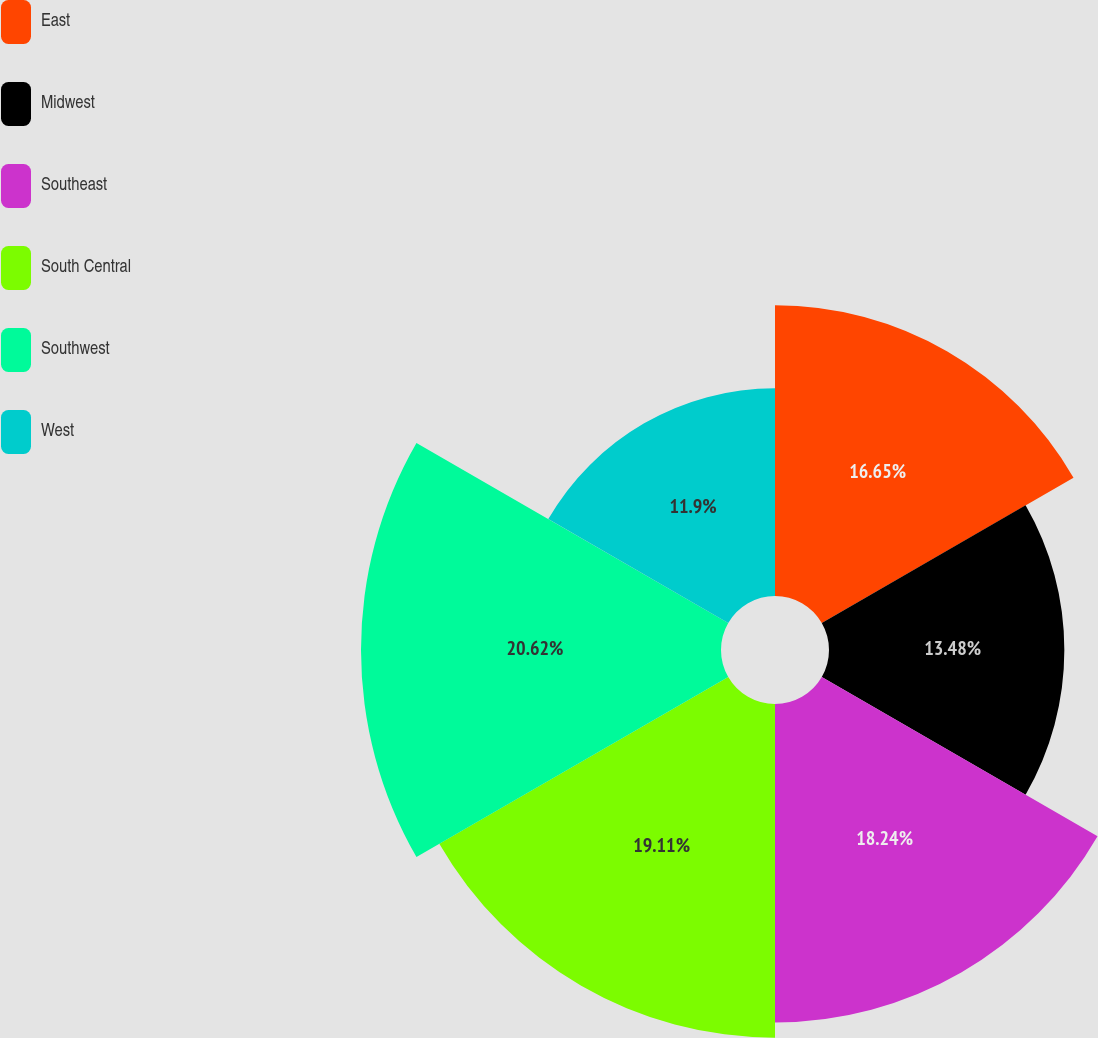<chart> <loc_0><loc_0><loc_500><loc_500><pie_chart><fcel>East<fcel>Midwest<fcel>Southeast<fcel>South Central<fcel>Southwest<fcel>West<nl><fcel>16.65%<fcel>13.48%<fcel>18.24%<fcel>19.11%<fcel>20.62%<fcel>11.9%<nl></chart> 